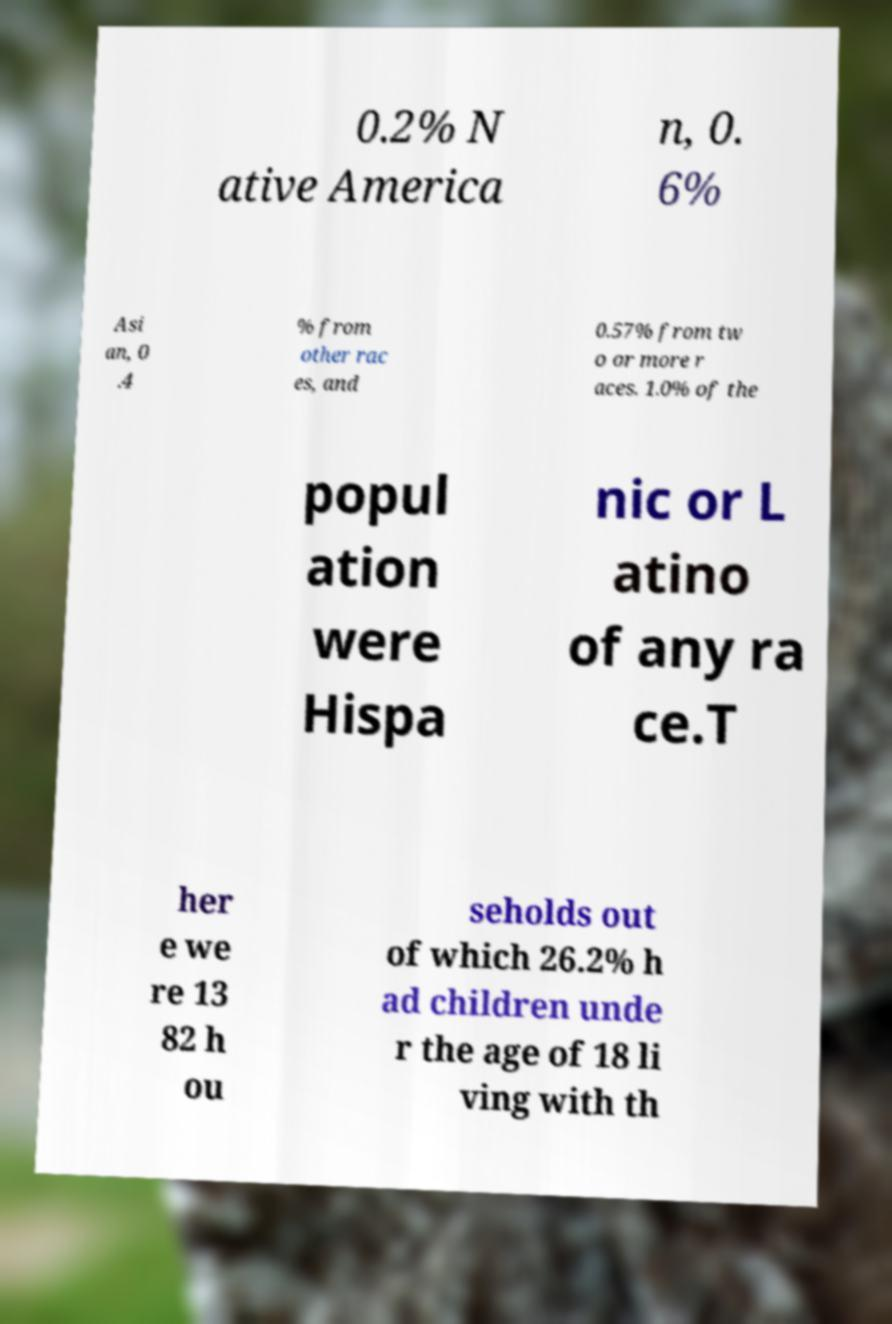Please identify and transcribe the text found in this image. 0.2% N ative America n, 0. 6% Asi an, 0 .4 % from other rac es, and 0.57% from tw o or more r aces. 1.0% of the popul ation were Hispa nic or L atino of any ra ce.T her e we re 13 82 h ou seholds out of which 26.2% h ad children unde r the age of 18 li ving with th 